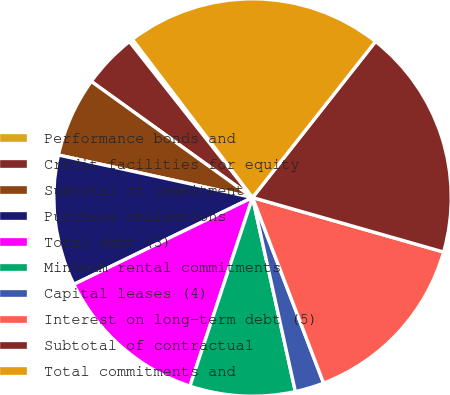Convert chart. <chart><loc_0><loc_0><loc_500><loc_500><pie_chart><fcel>Performance bonds and<fcel>Credit facilities for equity<fcel>Subtotal of commitment<fcel>Purchase obligations<fcel>Total debt (3)<fcel>Minimum rental commitments<fcel>Capital leases (4)<fcel>Interest on long-term debt (5)<fcel>Subtotal of contractual<fcel>Total commitments and<nl><fcel>0.3%<fcel>4.43%<fcel>6.5%<fcel>10.63%<fcel>12.7%<fcel>8.56%<fcel>2.36%<fcel>14.76%<fcel>18.8%<fcel>20.96%<nl></chart> 